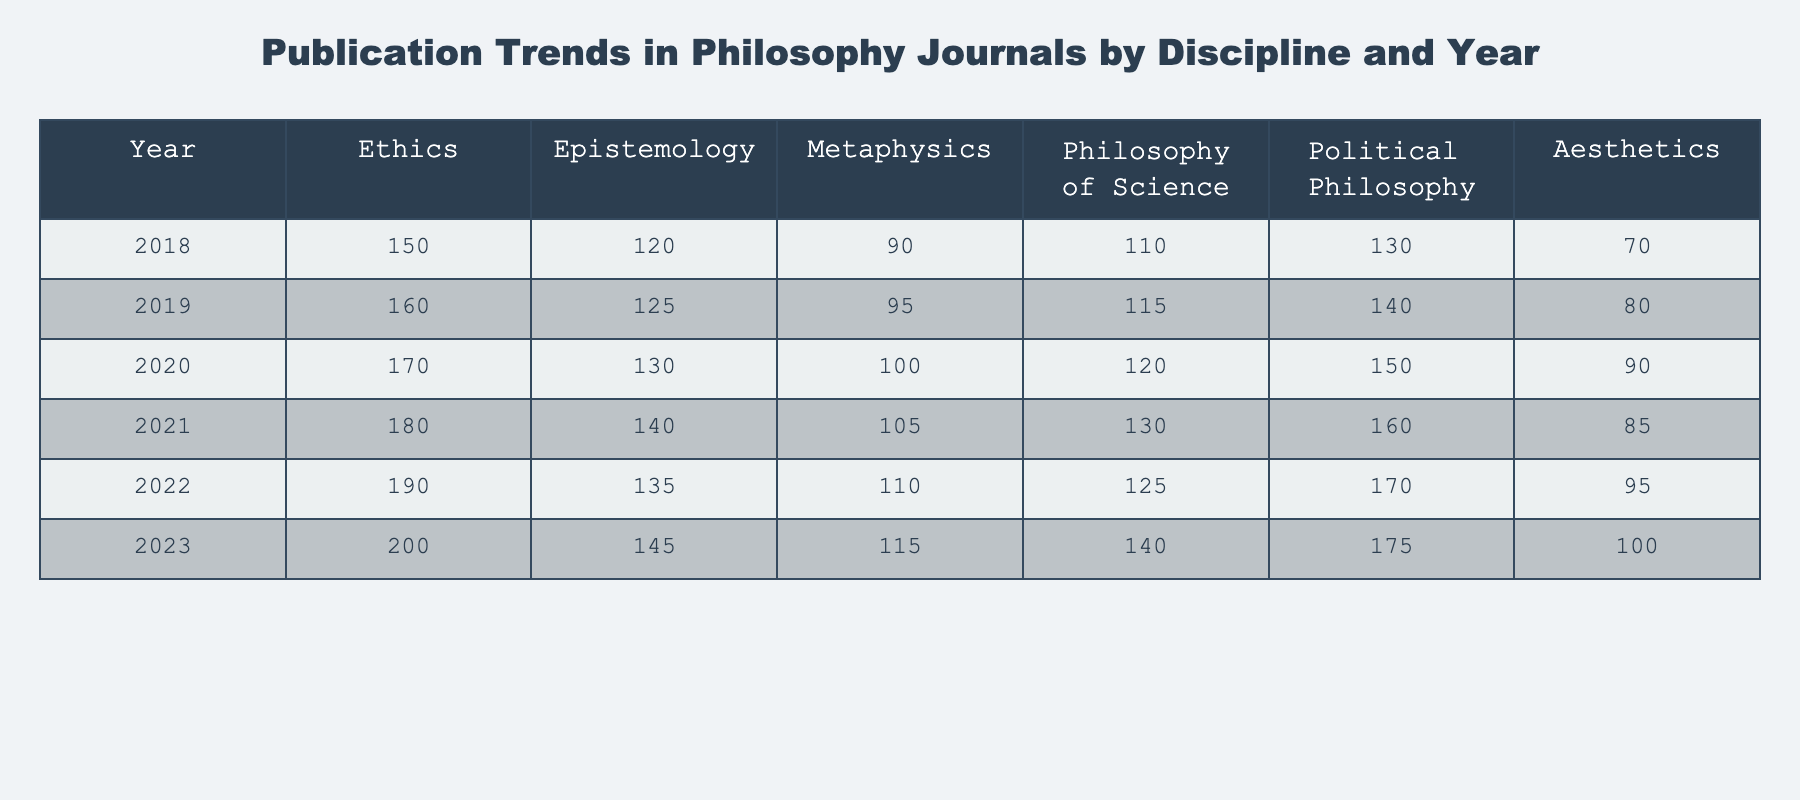What was the publication count for Ethics in 2021? The table shows the count for Ethics in the year 2021 directly in the relevant cell. Referring to the table, the value is 180.
Answer: 180 What is the total number of publications in Metaphysics from 2018 to 2023? To find the total for Metaphysics, I sum the values for each year: (90 + 95 + 100 + 105 + 110 + 115) = 615.
Answer: 615 Did the publication count for Political Philosophy increase from 2021 to 2023? Comparing the values for Political Philosophy in 2021 (160) and 2023 (175), the count has indeed increased.
Answer: Yes What was the average number of publications in Aesthetics over the years? To calculate the average, I sum the Aesthetics values for each year: (70 + 80 + 90 + 85 + 95 + 100) = 520. Then, I divide by the number of years (6): 520/6 = 86.67.
Answer: 86.67 What is the difference in publication count between Ethics and Philosophy of Science in 2020? In 2020, Ethics had 170 publications, while Philosophy of Science had 120. The difference is 170 - 120 = 50.
Answer: 50 Which discipline had the highest publication count in 2022, and what was the count? Looking at the values for 2022, Ethics has 190, Epistemology has 135, Metaphysics has 110, Philosophy of Science has 125, Political Philosophy has 170, and Aesthetics has 95. The highest count is 190 for Ethics.
Answer: Ethics, 190 What is the trend for Epistemology from 2018 to 2023? Observing the values, Epistemology's publications are as follows: 120 (2018), 125 (2019), 130 (2020), 140 (2021), 135 (2022), 145 (2023). There is a general upward trend, but a slight dip in 2022.
Answer: Overall upward trend with a dip in 2022 How did the publication count for Metaphysics in 2022 compare to that in 2018? In 2022, Metaphysics had 110 publications, while in 2018 it had 90. The count in 2022 is higher than that in 2018 by a difference of 20 publications.
Answer: Higher by 20 What was the least published discipline in 2019? Looking at the publication counts for 2019: Ethics (160), Epistemology (125), Metaphysics (95), Philosophy of Science (115), Political Philosophy (140), and Aesthetics (80), the least published discipline is Aesthetics with a count of 80.
Answer: Aesthetics, 80 